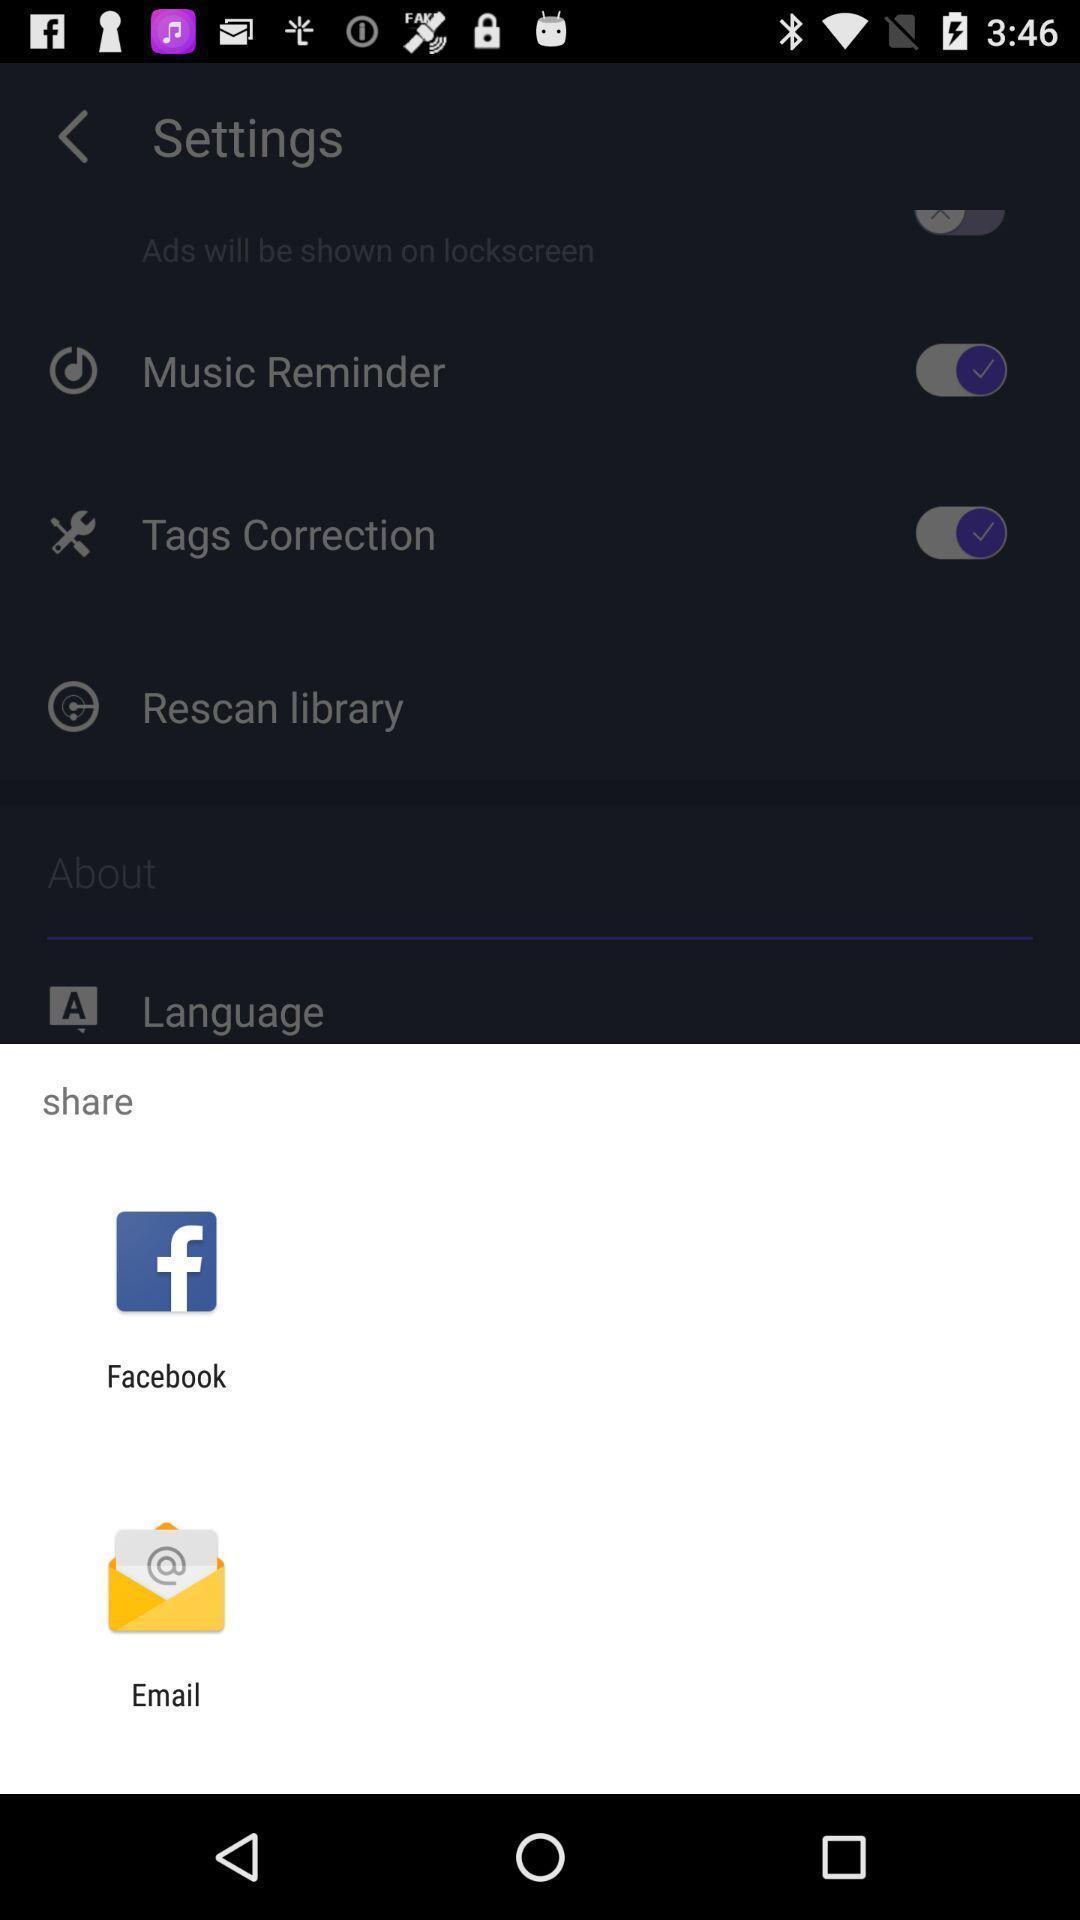Explain what's happening in this screen capture. Popup showing different apps to share. 